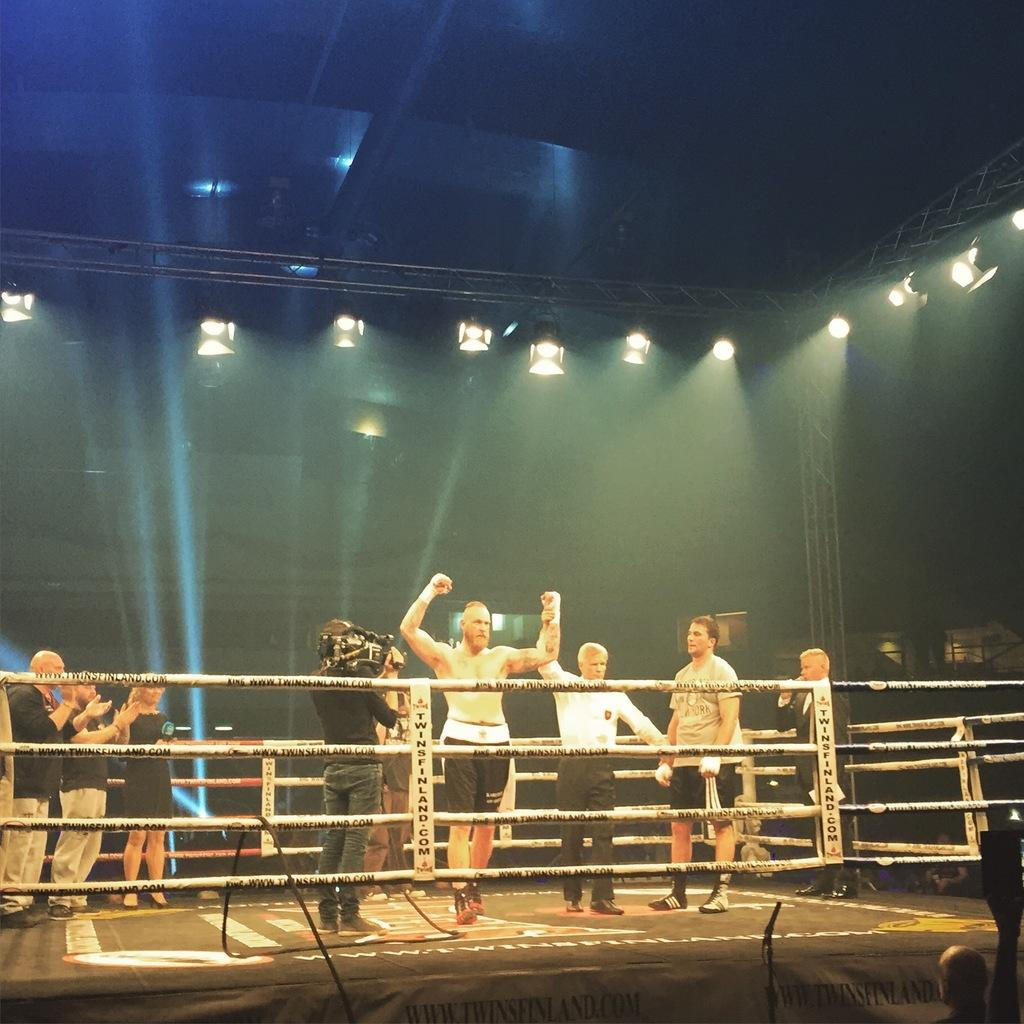What is happening in the image? There are people standing in the image. What can be seen at the top of the image? There are lights visible at the top of the image. How does the tramp help people in the image? There is no tramp present in the image, so it cannot help people in the image. 